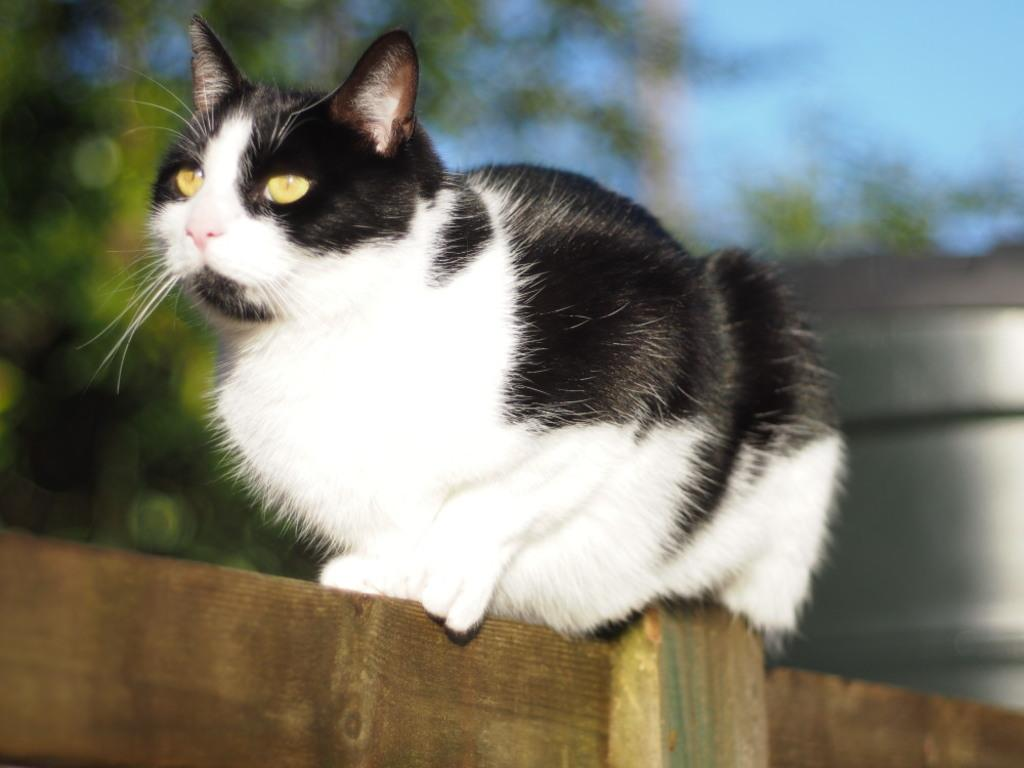What type of animal is in the image? There is a cat in the image. Where is the cat located? The cat is on a wooden wall. What can be seen in the background of the image? There are trees in the background of the image. What is visible at the top of the image? The sky is visible at the top of the image. How many snails are crawling on the cat's tail in the image? There are no snails present in the image, and therefore no snails can be observed on the cat's tail. 